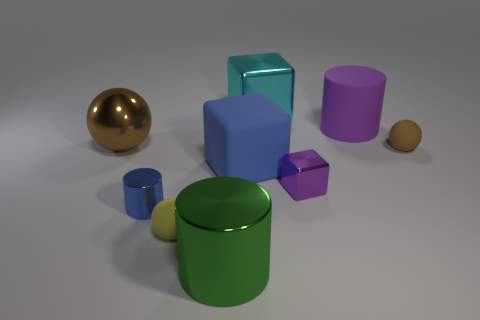Subtract all small cylinders. How many cylinders are left? 2 Subtract all red cubes. How many brown spheres are left? 2 Subtract 1 cubes. How many cubes are left? 2 Add 1 brown rubber cylinders. How many objects exist? 10 Subtract all gray cylinders. Subtract all cyan cubes. How many cylinders are left? 3 Subtract all cylinders. How many objects are left? 6 Subtract 0 green balls. How many objects are left? 9 Subtract all brown metallic objects. Subtract all big cyan blocks. How many objects are left? 7 Add 6 tiny rubber objects. How many tiny rubber objects are left? 8 Add 9 yellow matte things. How many yellow matte things exist? 10 